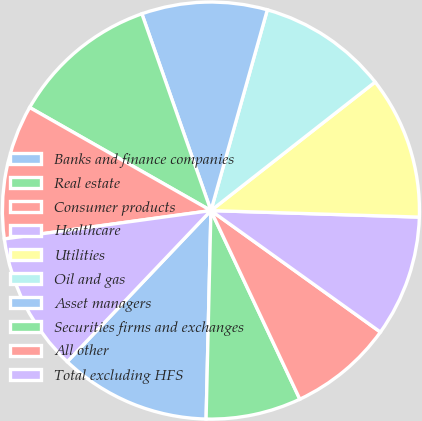Convert chart to OTSL. <chart><loc_0><loc_0><loc_500><loc_500><pie_chart><fcel>Banks and finance companies<fcel>Real estate<fcel>Consumer products<fcel>Healthcare<fcel>Utilities<fcel>Oil and gas<fcel>Asset managers<fcel>Securities firms and exchanges<fcel>All other<fcel>Total excluding HFS<nl><fcel>11.73%<fcel>7.38%<fcel>8.09%<fcel>9.4%<fcel>11.07%<fcel>10.07%<fcel>9.73%<fcel>11.4%<fcel>10.4%<fcel>10.73%<nl></chart> 